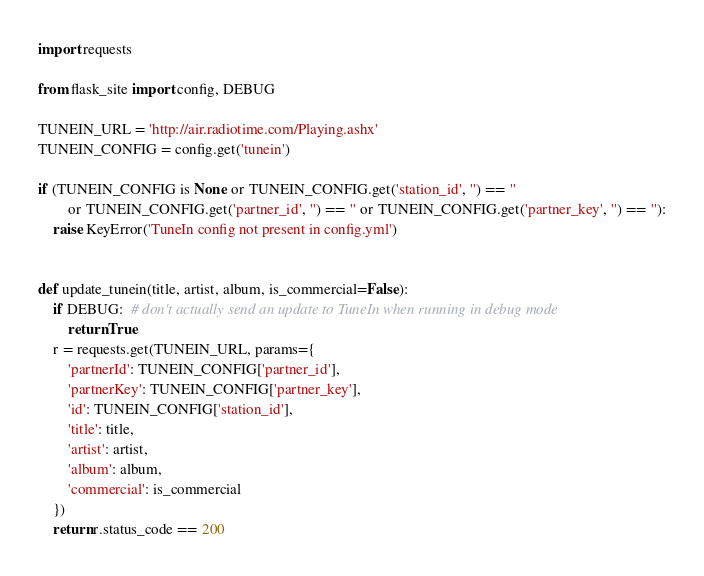<code> <loc_0><loc_0><loc_500><loc_500><_Python_>import requests

from flask_site import config, DEBUG

TUNEIN_URL = 'http://air.radiotime.com/Playing.ashx'
TUNEIN_CONFIG = config.get('tunein')

if (TUNEIN_CONFIG is None or TUNEIN_CONFIG.get('station_id', '') == ''
        or TUNEIN_CONFIG.get('partner_id', '') == '' or TUNEIN_CONFIG.get('partner_key', '') == ''):
    raise KeyError('TuneIn config not present in config.yml')


def update_tunein(title, artist, album, is_commercial=False):
    if DEBUG:  # don't actually send an update to TuneIn when running in debug mode
        return True
    r = requests.get(TUNEIN_URL, params={
        'partnerId': TUNEIN_CONFIG['partner_id'],
        'partnerKey': TUNEIN_CONFIG['partner_key'],
        'id': TUNEIN_CONFIG['station_id'],
        'title': title,
        'artist': artist,
        'album': album,
        'commercial': is_commercial
    })
    return r.status_code == 200
</code> 